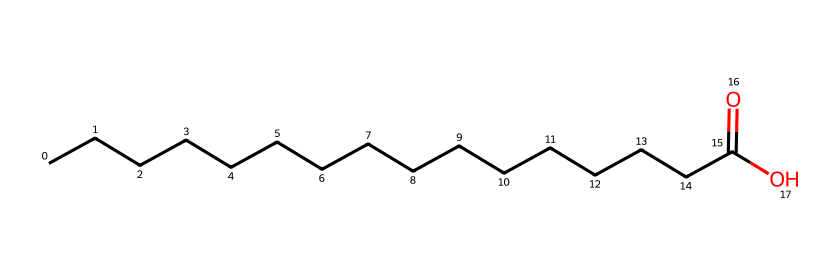How many carbon atoms are in this molecule? The SMILES representation indicates a long carbon chain represented by "CCCCCCCCCCCCCCCC", which shows that there are a total of 16 carbon atoms before the functional group.
Answer: 16 What type of functional group is present in this molecule? The "C(=O)O" part of the SMILES indicates a carboxylic acid functional group, which is characterized by a carbon atom double-bonded to an oxygen atom and single-bonded to a hydroxyl group (-OH).
Answer: carboxylic acid Is this compound saturated or unsaturated? The presence of single bonds only between carbon atoms (indicated by "C" and no double bonds between carbon chains), along with a single functional carboxylic acid group, signifies that it is a saturated fatty acid.
Answer: saturated What is the common use of this molecule in art preservation? This molecule, being a fatty acid, can be used in protective coatings, preserving the integrity of artworks, particularly those that may be damaged by moisture or environmental factors.
Answer: coating How does the length of the carbon chain affect the properties of this lubricant? A longer carbon chain typically enhances the viscosity and stability of the lubricant, which can improve its effectiveness in reducing friction and wear in preservation applications.
Answer: viscosity What is the primary natural source of this molecule? This compound is primarily derived from the oil extracted from palm fruit, a significant agricultural product in many African regions, linking it to cultural heritage.
Answer: palm oil 